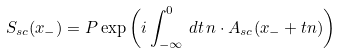<formula> <loc_0><loc_0><loc_500><loc_500>S _ { s c } ( x _ { - } ) = P \exp \left ( i \int _ { - \infty } ^ { 0 } \, d t \, n \cdot A _ { s c } ( x _ { - } + t n ) \right )</formula> 